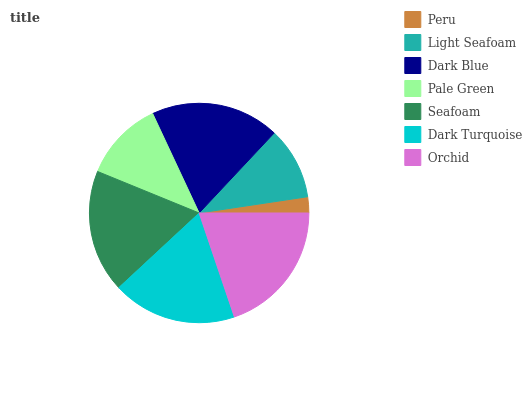Is Peru the minimum?
Answer yes or no. Yes. Is Orchid the maximum?
Answer yes or no. Yes. Is Light Seafoam the minimum?
Answer yes or no. No. Is Light Seafoam the maximum?
Answer yes or no. No. Is Light Seafoam greater than Peru?
Answer yes or no. Yes. Is Peru less than Light Seafoam?
Answer yes or no. Yes. Is Peru greater than Light Seafoam?
Answer yes or no. No. Is Light Seafoam less than Peru?
Answer yes or no. No. Is Seafoam the high median?
Answer yes or no. Yes. Is Seafoam the low median?
Answer yes or no. Yes. Is Peru the high median?
Answer yes or no. No. Is Orchid the low median?
Answer yes or no. No. 